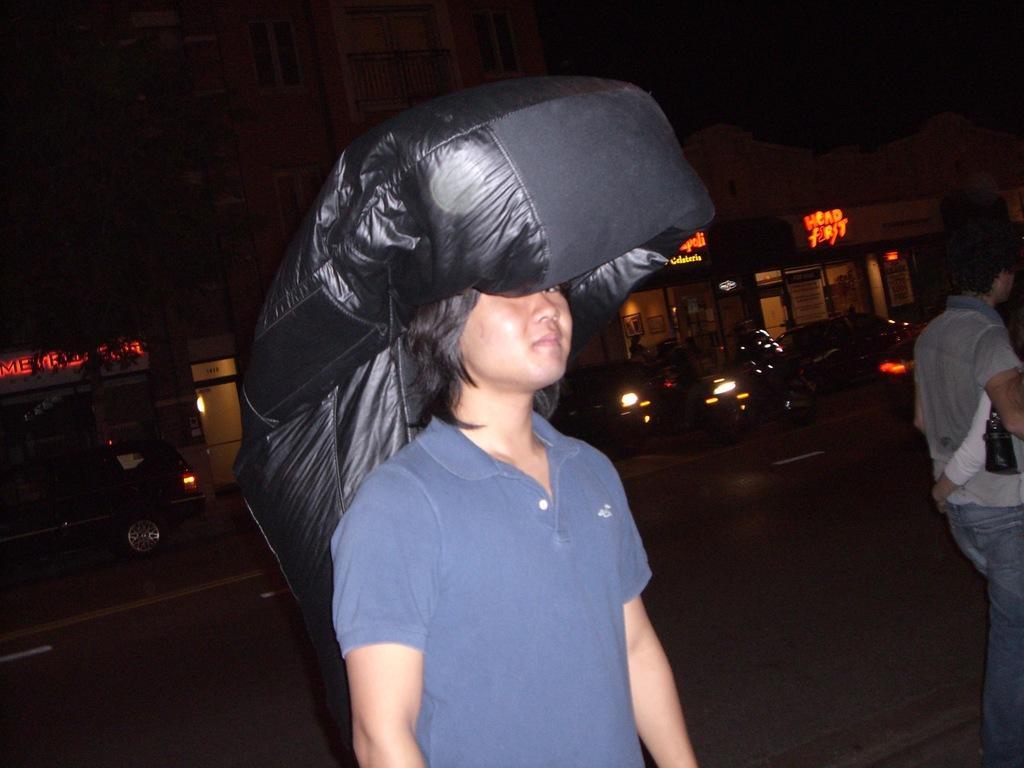In one or two sentences, can you explain what this image depicts? In this image I can see few people with different color dresses. There is a black color object on one of the person. To the side there is a road. On the road I can see many vehicles with lights. In the background I can see the building. 